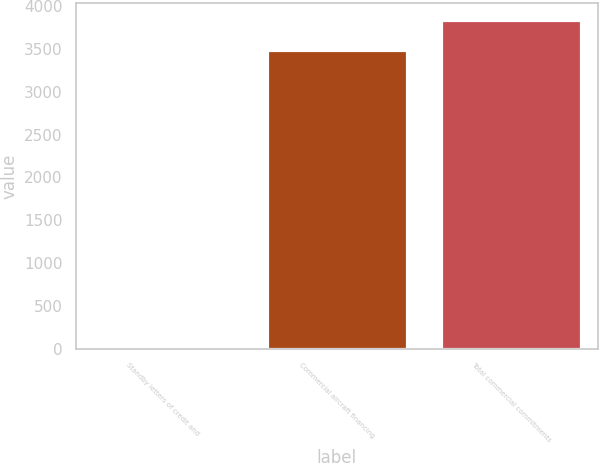<chart> <loc_0><loc_0><loc_500><loc_500><bar_chart><fcel>Standby letters of credit and<fcel>Commercial aircraft financing<fcel>Total commercial commitments<nl><fcel>3<fcel>3493<fcel>3842.3<nl></chart> 